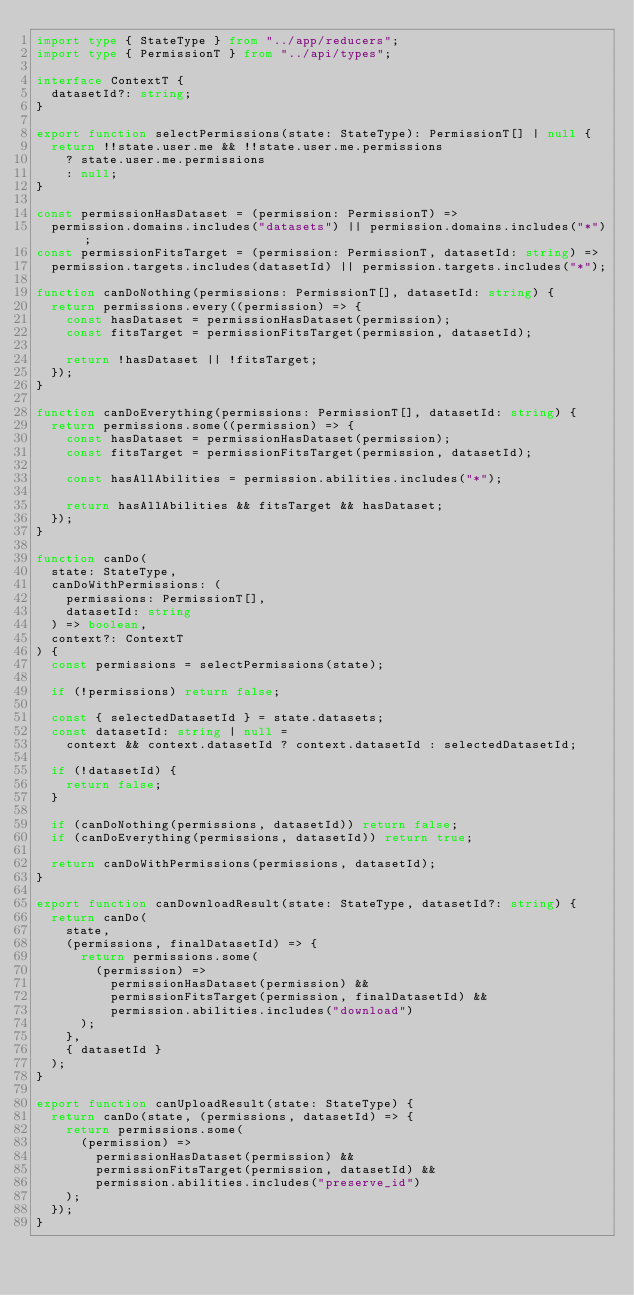<code> <loc_0><loc_0><loc_500><loc_500><_TypeScript_>import type { StateType } from "../app/reducers";
import type { PermissionT } from "../api/types";

interface ContextT {
  datasetId?: string;
}

export function selectPermissions(state: StateType): PermissionT[] | null {
  return !!state.user.me && !!state.user.me.permissions
    ? state.user.me.permissions
    : null;
}

const permissionHasDataset = (permission: PermissionT) =>
  permission.domains.includes("datasets") || permission.domains.includes("*");
const permissionFitsTarget = (permission: PermissionT, datasetId: string) =>
  permission.targets.includes(datasetId) || permission.targets.includes("*");

function canDoNothing(permissions: PermissionT[], datasetId: string) {
  return permissions.every((permission) => {
    const hasDataset = permissionHasDataset(permission);
    const fitsTarget = permissionFitsTarget(permission, datasetId);

    return !hasDataset || !fitsTarget;
  });
}

function canDoEverything(permissions: PermissionT[], datasetId: string) {
  return permissions.some((permission) => {
    const hasDataset = permissionHasDataset(permission);
    const fitsTarget = permissionFitsTarget(permission, datasetId);

    const hasAllAbilities = permission.abilities.includes("*");

    return hasAllAbilities && fitsTarget && hasDataset;
  });
}

function canDo(
  state: StateType,
  canDoWithPermissions: (
    permissions: PermissionT[],
    datasetId: string
  ) => boolean,
  context?: ContextT
) {
  const permissions = selectPermissions(state);

  if (!permissions) return false;

  const { selectedDatasetId } = state.datasets;
  const datasetId: string | null =
    context && context.datasetId ? context.datasetId : selectedDatasetId;

  if (!datasetId) {
    return false;
  }

  if (canDoNothing(permissions, datasetId)) return false;
  if (canDoEverything(permissions, datasetId)) return true;

  return canDoWithPermissions(permissions, datasetId);
}

export function canDownloadResult(state: StateType, datasetId?: string) {
  return canDo(
    state,
    (permissions, finalDatasetId) => {
      return permissions.some(
        (permission) =>
          permissionHasDataset(permission) &&
          permissionFitsTarget(permission, finalDatasetId) &&
          permission.abilities.includes("download")
      );
    },
    { datasetId }
  );
}

export function canUploadResult(state: StateType) {
  return canDo(state, (permissions, datasetId) => {
    return permissions.some(
      (permission) =>
        permissionHasDataset(permission) &&
        permissionFitsTarget(permission, datasetId) &&
        permission.abilities.includes("preserve_id")
    );
  });
}
</code> 